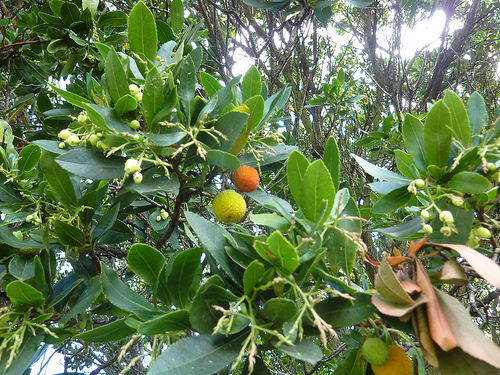<image>
Is the fruit on the other fruit? No. The fruit is not positioned on the other fruit. They may be near each other, but the fruit is not supported by or resting on top of the other fruit. 